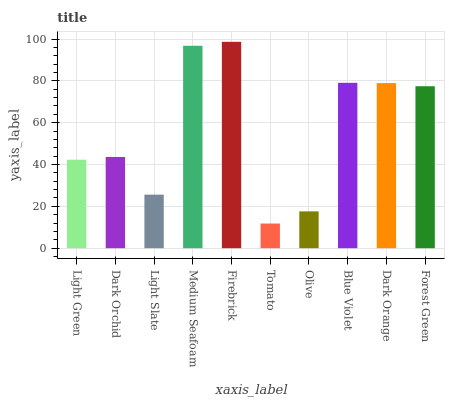Is Tomato the minimum?
Answer yes or no. Yes. Is Firebrick the maximum?
Answer yes or no. Yes. Is Dark Orchid the minimum?
Answer yes or no. No. Is Dark Orchid the maximum?
Answer yes or no. No. Is Dark Orchid greater than Light Green?
Answer yes or no. Yes. Is Light Green less than Dark Orchid?
Answer yes or no. Yes. Is Light Green greater than Dark Orchid?
Answer yes or no. No. Is Dark Orchid less than Light Green?
Answer yes or no. No. Is Forest Green the high median?
Answer yes or no. Yes. Is Dark Orchid the low median?
Answer yes or no. Yes. Is Blue Violet the high median?
Answer yes or no. No. Is Forest Green the low median?
Answer yes or no. No. 